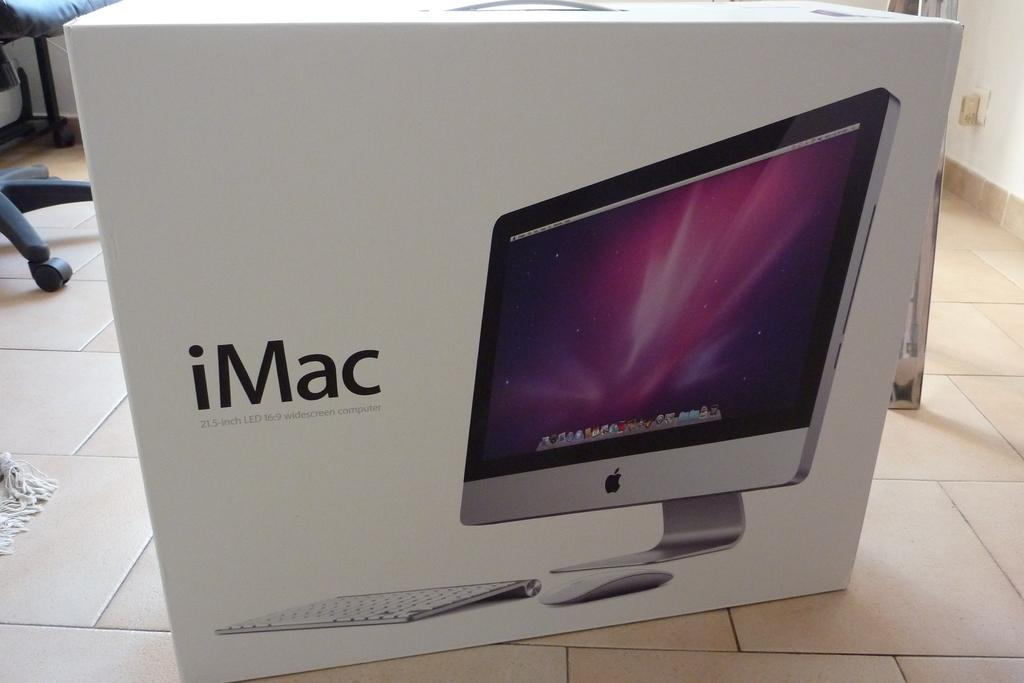<image>
Summarize the visual content of the image. An iMac box sits on a floor, an image of it on the box. 